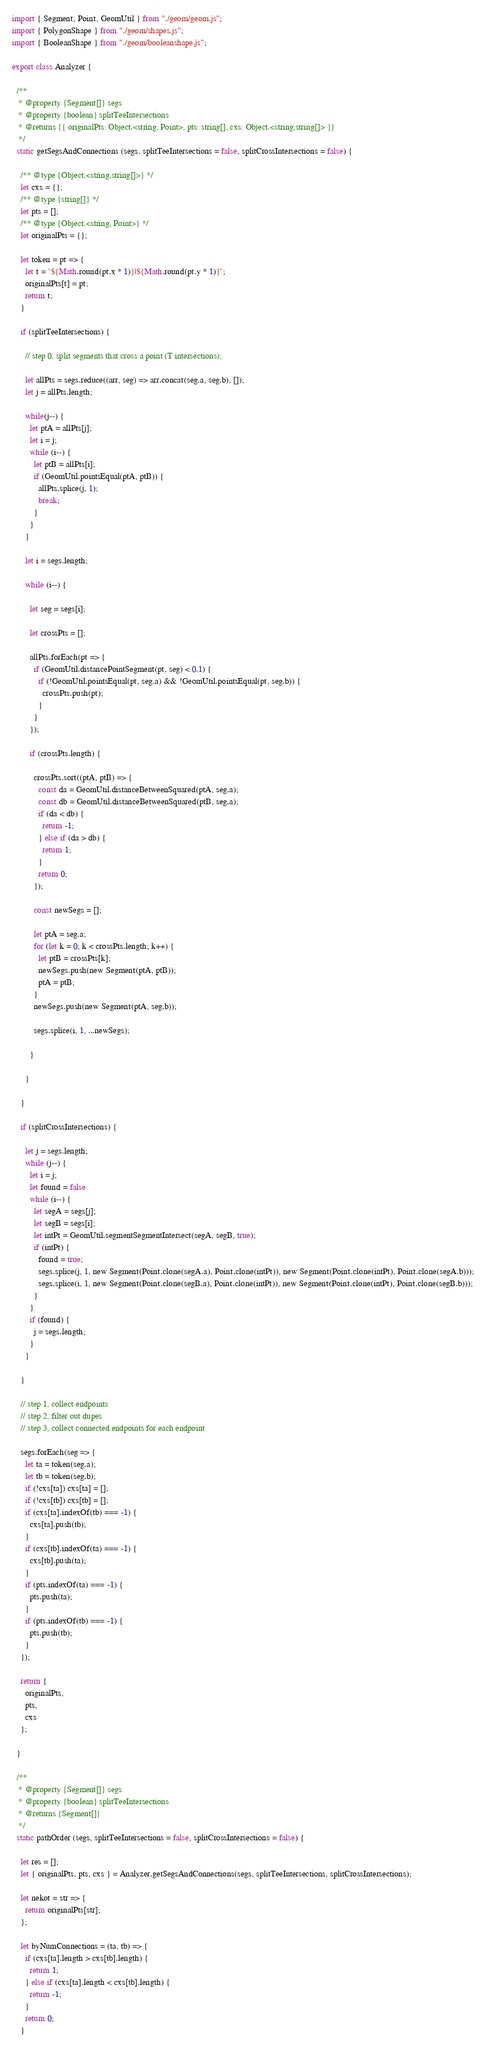Convert code to text. <code><loc_0><loc_0><loc_500><loc_500><_JavaScript_>import { Segment, Point, GeomUtil } from "./geom/geom.js";
import { PolygonShape } from "./geom/shapes.js";
import { BooleanShape } from "./geom/booleanshape.js";

export class Analyzer {
  
  /**
   * @property {Segment[]} segs
   * @property {boolean} splitTeeIntersections
   * @returns {{ originalPts: Object.<string, Point>, pts: string[], cxs: Object.<string,string[]> }}
   */
  static getSegsAndConnections (segs, splitTeeIntersections = false, splitCrossIntersections = false) {
    
    /** @type {Object.<string,string[]>} */
    let cxs = {};
    /** @type {string[]} */
    let pts = [];
    /** @type {Object.<string, Point>} */
    let originalPts = {};

    let token = pt => {
      let t = `${Math.round(pt.x * 1)}|${Math.round(pt.y * 1)}`;
      originalPts[t] = pt;
      return t;
    }

    if (splitTeeIntersections) {

      // step 0, split segments that cross a point (T intersections);

      let allPts = segs.reduce((arr, seg) => arr.concat(seg.a, seg.b), []);
      let j = allPts.length; 

      while(j--) {
        let ptA = allPts[j];
        let i = j;
        while (i--) {
          let ptB = allPts[i];
          if (GeomUtil.pointsEqual(ptA, ptB)) {
            allPts.splice(j, 1);
            break;
          }
        }
      }

      let i = segs.length;

      while (i--) {

        let seg = segs[i];

        let crossPts = [];

        allPts.forEach(pt => {
          if (GeomUtil.distancePointSegment(pt, seg) < 0.1) {
            if (!GeomUtil.pointsEqual(pt, seg.a) && !GeomUtil.pointsEqual(pt, seg.b)) {
              crossPts.push(pt);
            }
          }
        });

        if (crossPts.length) {

          crossPts.sort((ptA, ptB) => {
            const da = GeomUtil.distanceBetweenSquared(ptA, seg.a);
            const db = GeomUtil.distanceBetweenSquared(ptB, seg.a);
            if (da < db) {
              return -1; 
            } else if (da > db) {
              return 1;
            }
            return 0;
          });

          const newSegs = [];

          let ptA = seg.a;
          for (let k = 0; k < crossPts.length; k++) {
            let ptB = crossPts[k];
            newSegs.push(new Segment(ptA, ptB));
            ptA = ptB;
          }
          newSegs.push(new Segment(ptA, seg.b));

          segs.splice(i, 1, ...newSegs);

        }

      }

    }

    if (splitCrossIntersections) {

      let j = segs.length;
      while (j--) {
        let i = j;
        let found = false
        while (i--) {
          let segA = segs[j];
          let segB = segs[i];
          let intPt = GeomUtil.segmentSegmentIntersect(segA, segB, true);
          if (intPt) {
            found = true;
            segs.splice(j, 1, new Segment(Point.clone(segA.a), Point.clone(intPt)), new Segment(Point.clone(intPt), Point.clone(segA.b)));
            segs.splice(i, 1, new Segment(Point.clone(segB.a), Point.clone(intPt)), new Segment(Point.clone(intPt), Point.clone(segB.b)));
          }
        }
        if (found) {
          j = segs.length;
        }
      }

    }

    // step 1, collect endpoints
    // step 2, filter out dupes
    // step 3, collect connected endpoints for each endpoint

    segs.forEach(seg => {
      let ta = token(seg.a);
      let tb = token(seg.b);
      if (!cxs[ta]) cxs[ta] = [];
      if (!cxs[tb]) cxs[tb] = [];
      if (cxs[ta].indexOf(tb) === -1) {
        cxs[ta].push(tb);
      }
      if (cxs[tb].indexOf(ta) === -1) {
        cxs[tb].push(ta);
      }
      if (pts.indexOf(ta) === -1) {
        pts.push(ta);
      }
      if (pts.indexOf(tb) === -1) {
        pts.push(tb);
      }
    });

    return { 
      originalPts,
      pts,
      cxs
    };

  }

  /**
   * @property {Segment[]} segs
   * @property {boolean} splitTeeIntersections
   * @returns {Segment[]}
   */
  static pathOrder (segs, splitTeeIntersections = false, splitCrossIntersections = false) {

    let res = [];
    let { originalPts, pts, cxs } = Analyzer.getSegsAndConnections(segs, splitTeeIntersections, splitCrossIntersections);

    let nekot = str => {
      return originalPts[str];
    };

    let byNumConnections = (ta, tb) => {
      if (cxs[ta].length > cxs[tb].length) {
        return 1;
      } else if (cxs[ta].length < cxs[tb].length) {
        return -1;
      }
      return 0;
    }
</code> 